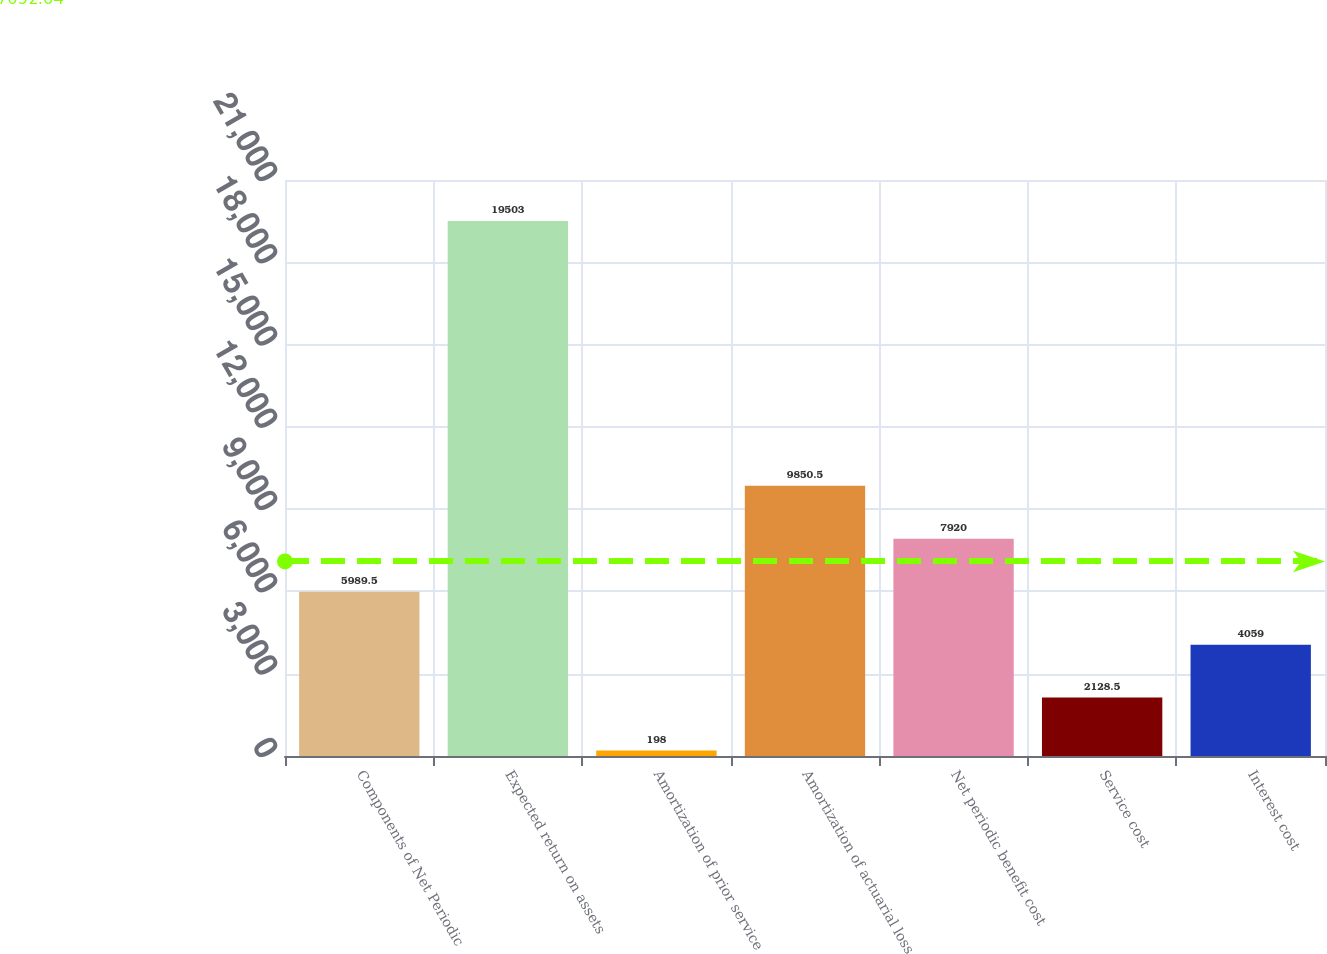Convert chart to OTSL. <chart><loc_0><loc_0><loc_500><loc_500><bar_chart><fcel>Components of Net Periodic<fcel>Expected return on assets<fcel>Amortization of prior service<fcel>Amortization of actuarial loss<fcel>Net periodic benefit cost<fcel>Service cost<fcel>Interest cost<nl><fcel>5989.5<fcel>19503<fcel>198<fcel>9850.5<fcel>7920<fcel>2128.5<fcel>4059<nl></chart> 